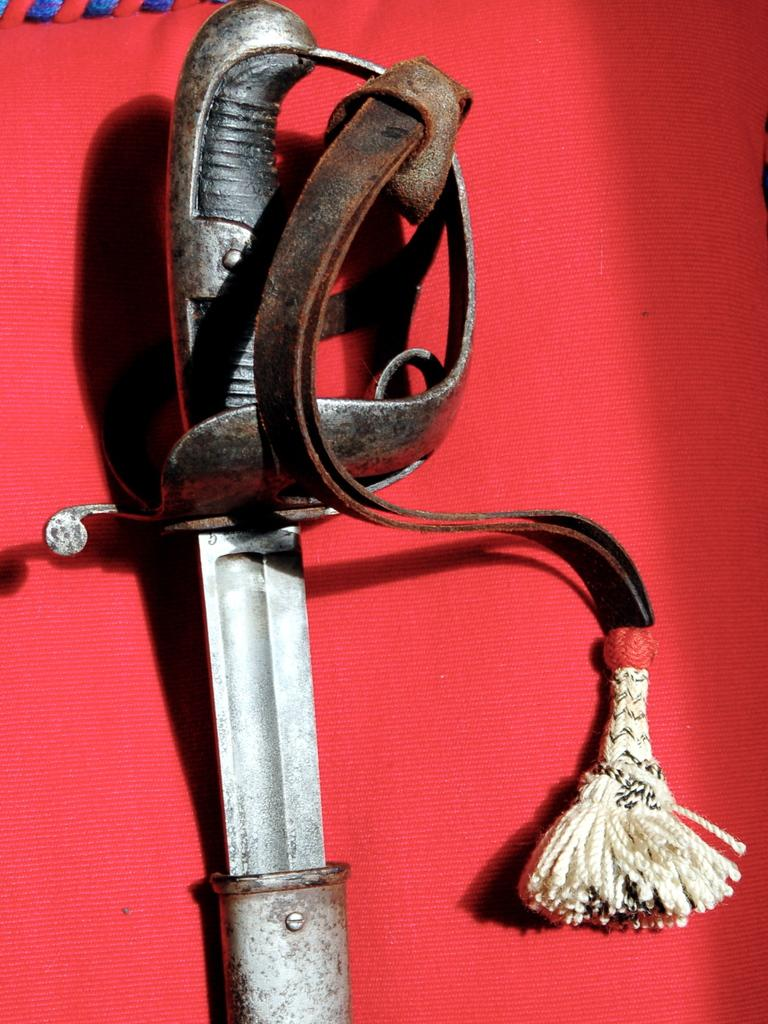What object can be seen in the image? There is a sword in the image. What color is the background of the image? The background of the image has a red color. Can you hear the creature sneezing in the image? There is no creature present in the image, and therefore no sneezing can be heard. What type of produce is visible in the image? There is no produce present in the image; it features a sword and a red background. 